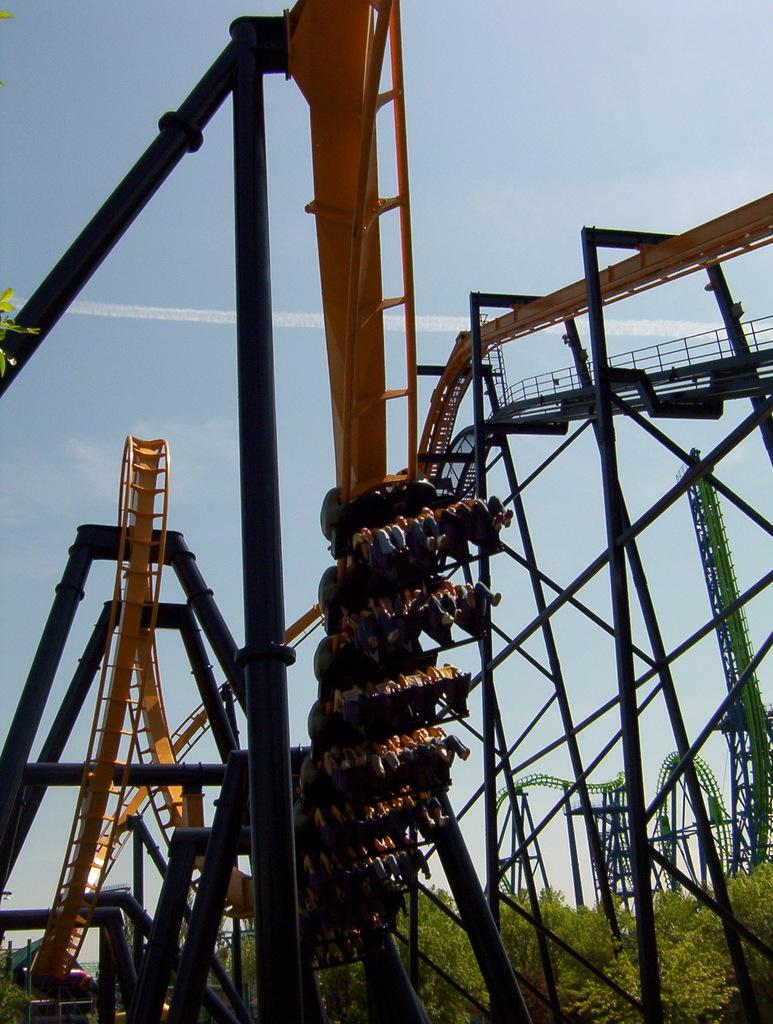What are the people in the image doing? The people in the image are sitting in a roller coaster. What is the main subject of the image? The roller coaster is in the image. What can be seen in the background of the image? There is a sky visible in the background of the image. What type of plant is growing on the stranger's head in the image? There is no stranger or plant present in the image. 